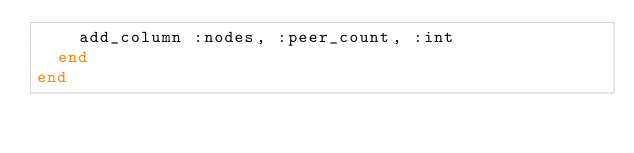<code> <loc_0><loc_0><loc_500><loc_500><_Ruby_>    add_column :nodes, :peer_count, :int
  end
end
</code> 